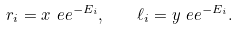Convert formula to latex. <formula><loc_0><loc_0><loc_500><loc_500>r _ { i } = x \ e e ^ { - E _ { i } } , \quad \ell _ { i } = y \ e e ^ { - E _ { i } } .</formula> 